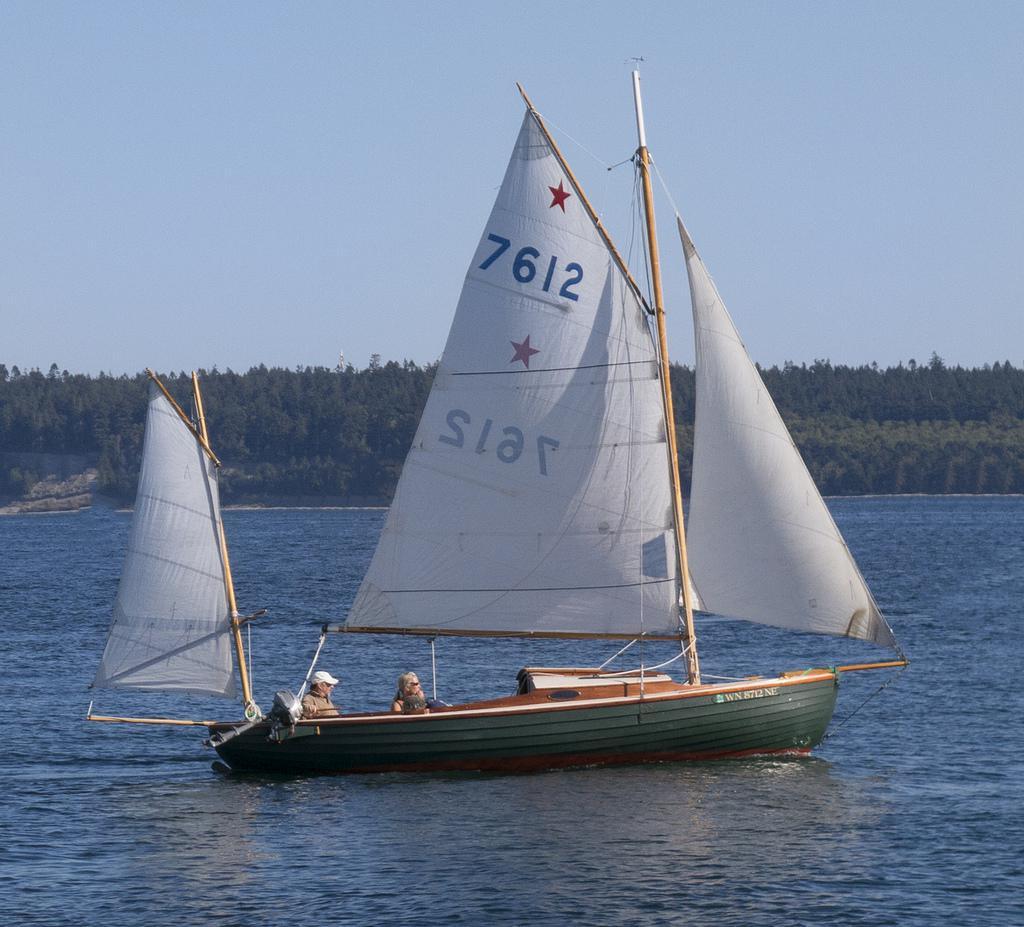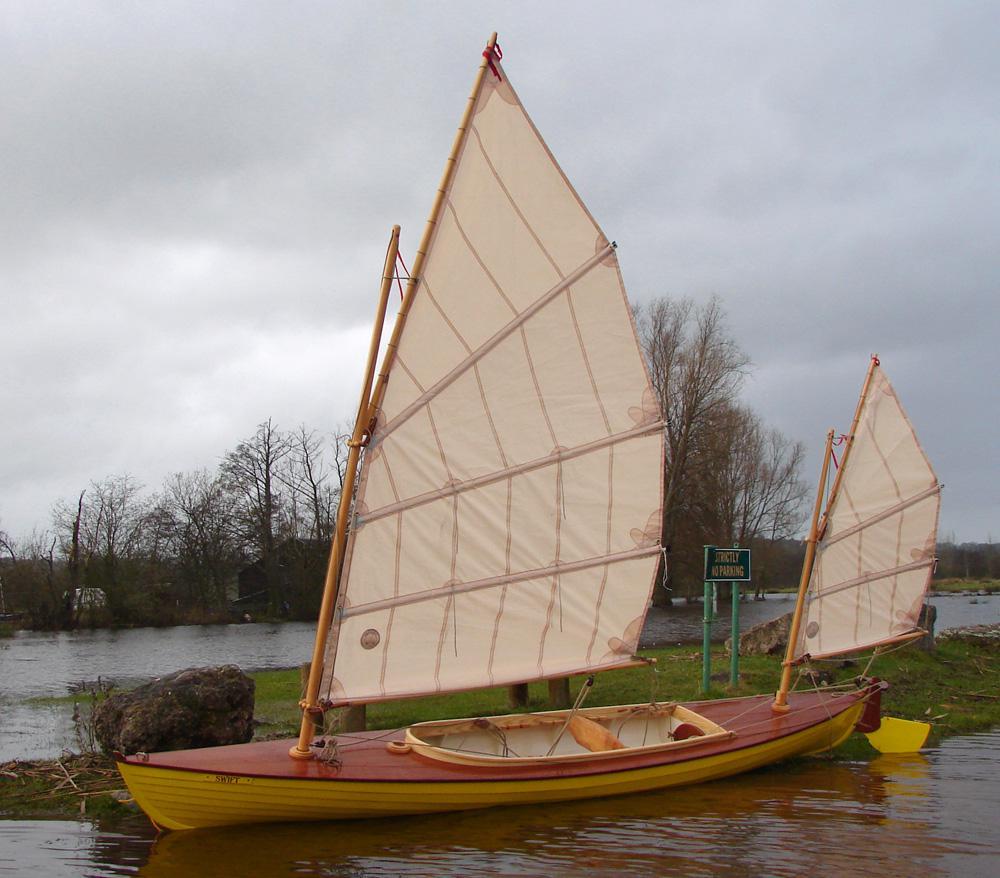The first image is the image on the left, the second image is the image on the right. Analyze the images presented: Is the assertion "There are 5 raised sails in the image pair" valid? Answer yes or no. Yes. The first image is the image on the left, the second image is the image on the right. For the images displayed, is the sentence "There are exactly five sails." factually correct? Answer yes or no. Yes. 